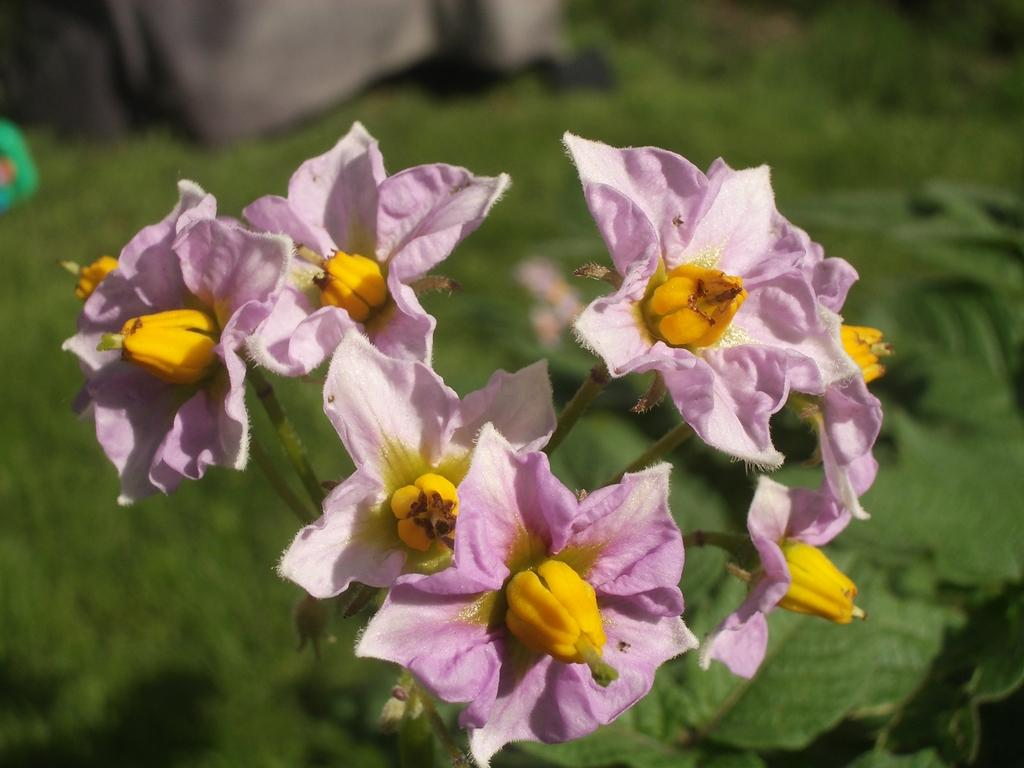What color are the flowers in the image? The flowers in the image are pink. What type of vegetation can be seen in the background of the image? There is greenery visible in the background of the image. Can you see an arch made of waves in the image? There is no arch made of waves present in the image. What is the condition of the person's knee in the image? There is no person or knee visible in the image. 